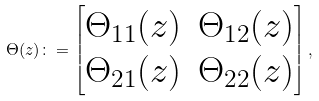<formula> <loc_0><loc_0><loc_500><loc_500>\Theta ( z ) \colon = \begin{bmatrix} \Theta _ { 1 1 } ( z ) & \Theta _ { 1 2 } ( z ) \\ \Theta _ { 2 1 } ( z ) & \Theta _ { 2 2 } ( z ) \end{bmatrix} ,</formula> 